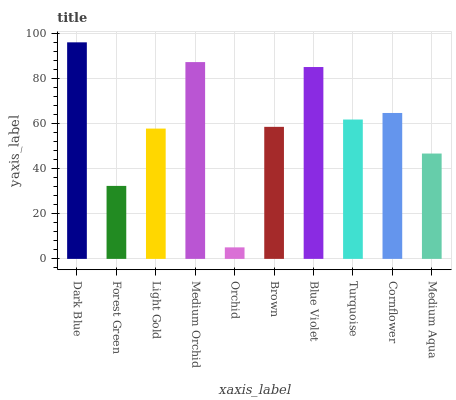Is Orchid the minimum?
Answer yes or no. Yes. Is Dark Blue the maximum?
Answer yes or no. Yes. Is Forest Green the minimum?
Answer yes or no. No. Is Forest Green the maximum?
Answer yes or no. No. Is Dark Blue greater than Forest Green?
Answer yes or no. Yes. Is Forest Green less than Dark Blue?
Answer yes or no. Yes. Is Forest Green greater than Dark Blue?
Answer yes or no. No. Is Dark Blue less than Forest Green?
Answer yes or no. No. Is Turquoise the high median?
Answer yes or no. Yes. Is Brown the low median?
Answer yes or no. Yes. Is Cornflower the high median?
Answer yes or no. No. Is Blue Violet the low median?
Answer yes or no. No. 